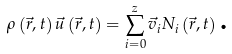Convert formula to latex. <formula><loc_0><loc_0><loc_500><loc_500>\rho \left ( \vec { r } , t \right ) \vec { u } \left ( \vec { r } , t \right ) = \sum _ { i = 0 } ^ { z } \vec { v } _ { i } N _ { i } \left ( \vec { r } , t \right ) \text {.}</formula> 